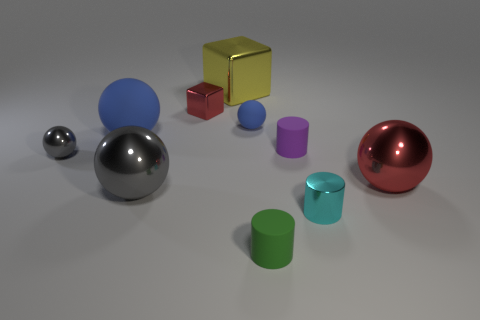Subtract all red metallic balls. How many balls are left? 4 Subtract all red cylinders. How many blue spheres are left? 2 Subtract all gray balls. How many balls are left? 3 Subtract all cubes. How many objects are left? 8 Add 2 blue objects. How many blue objects are left? 4 Add 4 red metallic balls. How many red metallic balls exist? 5 Subtract 0 cyan blocks. How many objects are left? 10 Subtract all red cylinders. Subtract all blue spheres. How many cylinders are left? 3 Subtract all small cyan rubber things. Subtract all small purple objects. How many objects are left? 9 